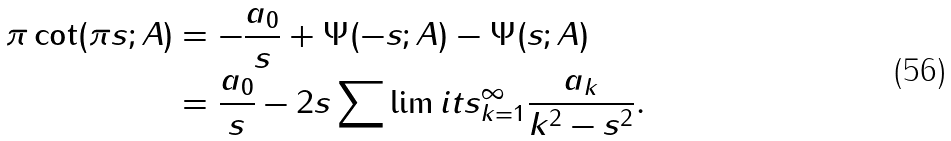Convert formula to latex. <formula><loc_0><loc_0><loc_500><loc_500>\pi \cot ( { \pi s ; A } ) & = - \frac { a _ { 0 } } { s } + \Psi ( { - s ; A } ) - \Psi ( { s ; A } ) \\ & = \frac { a _ { 0 } } { s } - 2 s \sum \lim i t s _ { k = 1 } ^ { \infty } { \frac { a _ { k } } { { { k ^ { 2 } } - { s ^ { 2 } } } } } .</formula> 